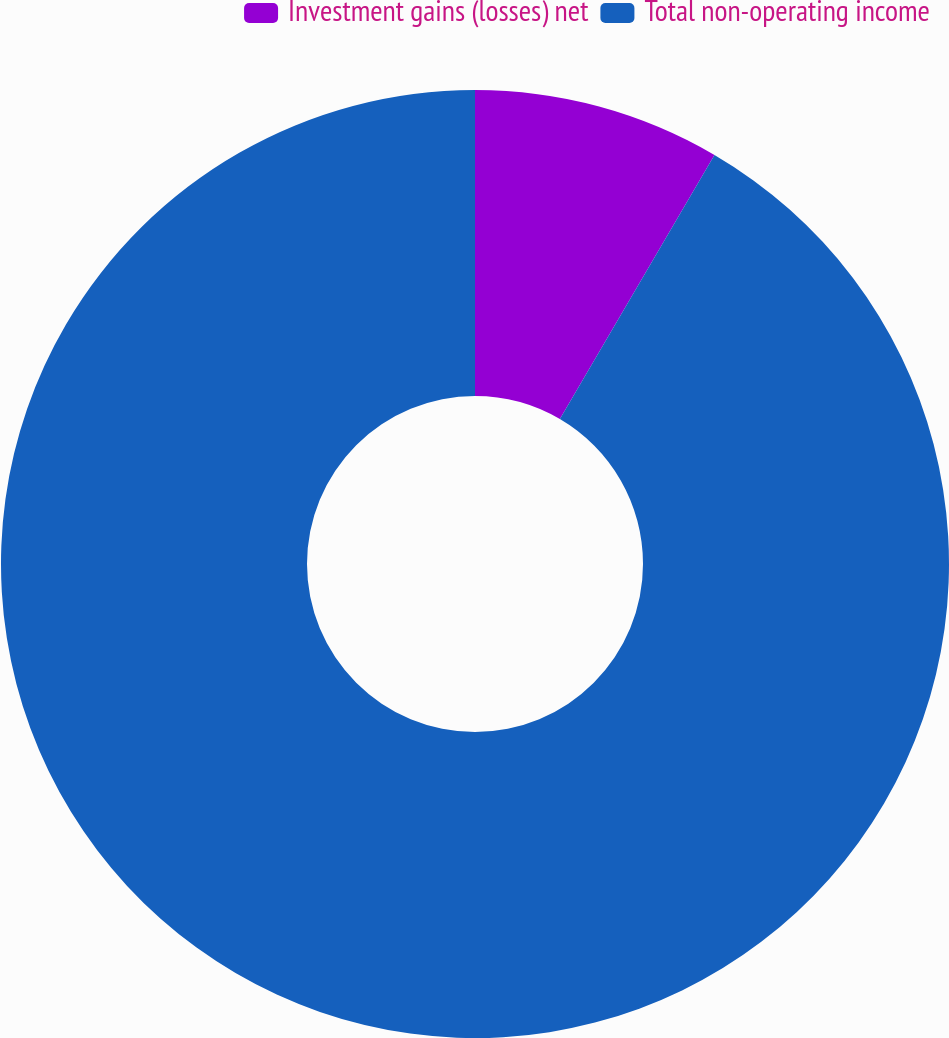<chart> <loc_0><loc_0><loc_500><loc_500><pie_chart><fcel>Investment gains (losses) net<fcel>Total non-operating income<nl><fcel>8.43%<fcel>91.57%<nl></chart> 